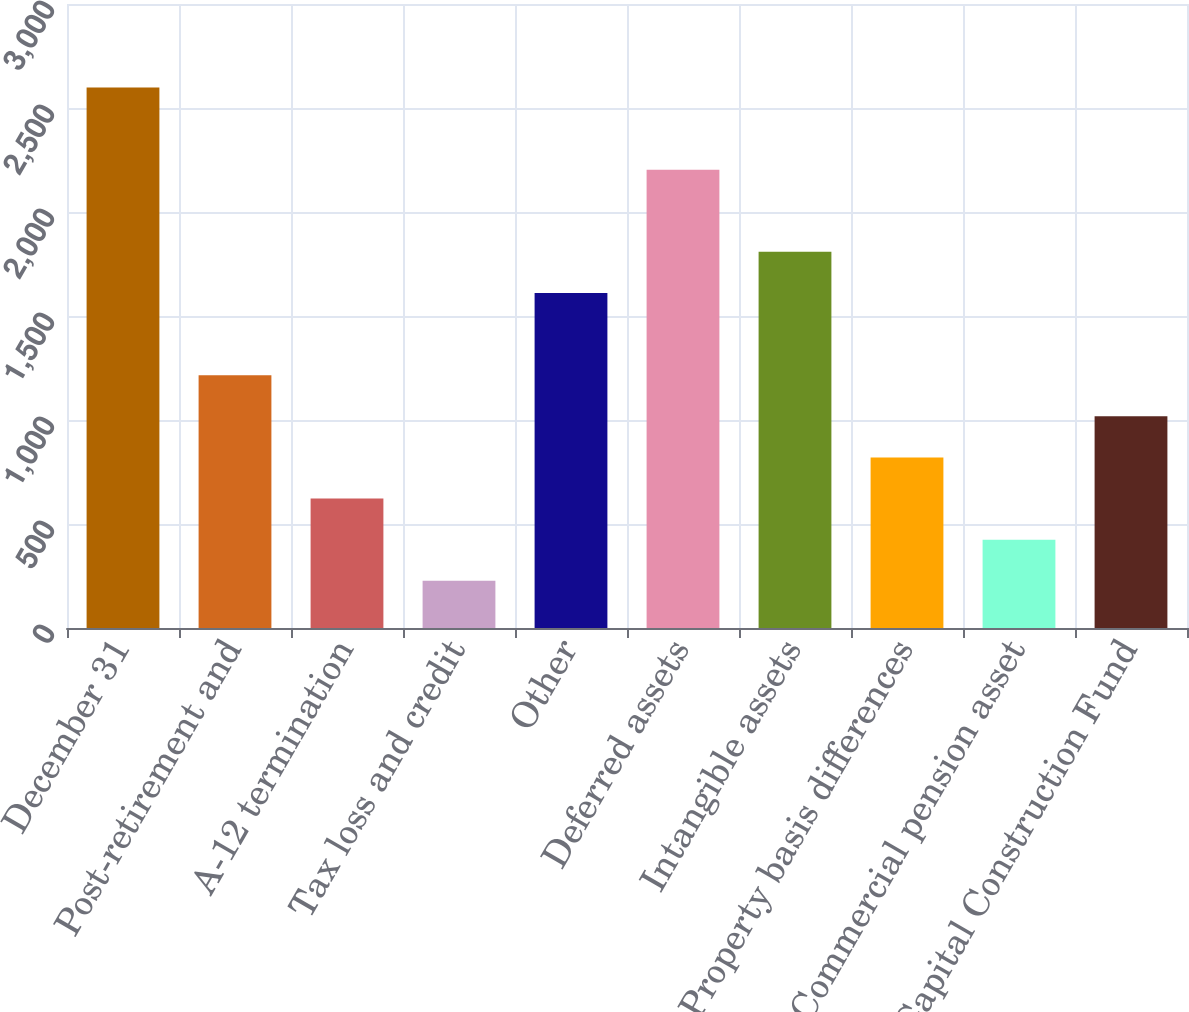Convert chart to OTSL. <chart><loc_0><loc_0><loc_500><loc_500><bar_chart><fcel>December 31<fcel>Post-retirement and<fcel>A-12 termination<fcel>Tax loss and credit<fcel>Other<fcel>Deferred assets<fcel>Intangible assets<fcel>Property basis differences<fcel>Commercial pension asset<fcel>Capital Construction Fund<nl><fcel>2599.1<fcel>1215.2<fcel>622.1<fcel>226.7<fcel>1610.6<fcel>2203.7<fcel>1808.3<fcel>819.8<fcel>424.4<fcel>1017.5<nl></chart> 